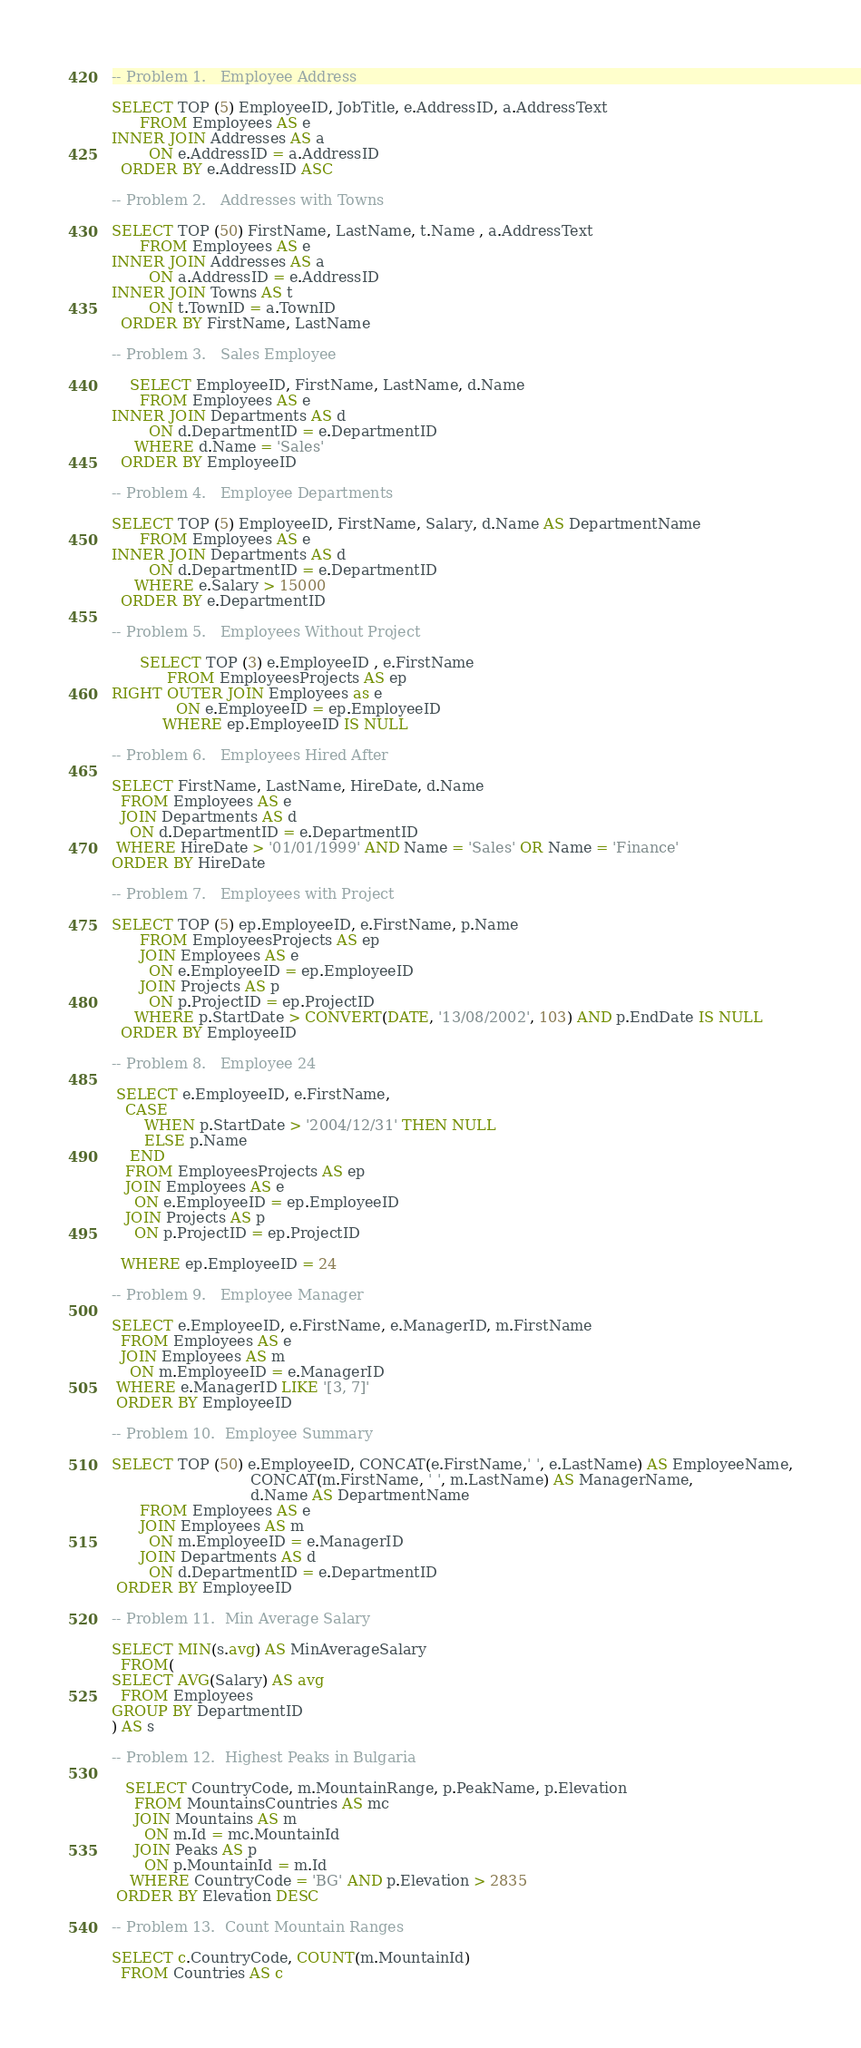Convert code to text. <code><loc_0><loc_0><loc_500><loc_500><_SQL_>-- Problem 1.	Employee Address

SELECT TOP (5) EmployeeID, JobTitle, e.AddressID, a.AddressText
      FROM Employees AS e
INNER JOIN Addresses AS a
        ON e.AddressID = a.AddressID
  ORDER BY e.AddressID ASC

-- Problem 2.	Addresses with Towns

SELECT TOP (50) FirstName, LastName, t.Name , a.AddressText
      FROM Employees AS e
INNER JOIN Addresses AS a
        ON a.AddressID = e.AddressID
INNER JOIN Towns AS t
        ON t.TownID = a.TownID
  ORDER BY FirstName, LastName

-- Problem 3.	Sales Employee

    SELECT EmployeeID, FirstName, LastName, d.Name
      FROM Employees AS e
INNER JOIN Departments AS d
        ON d.DepartmentID = e.DepartmentID
	 WHERE d.Name = 'Sales'
  ORDER BY EmployeeID

-- Problem 4.	Employee Departments

SELECT TOP (5) EmployeeID, FirstName, Salary, d.Name AS DepartmentName
      FROM Employees AS e
INNER JOIN Departments AS d
        ON d.DepartmentID = e.DepartmentID
	 WHERE e.Salary > 15000
  ORDER BY e.DepartmentID

-- Problem 5.	Employees Without Project

      SELECT TOP (3) e.EmployeeID , e.FirstName
            FROM EmployeesProjects AS ep
RIGHT OUTER JOIN Employees as e
              ON e.EmployeeID = ep.EmployeeID
           WHERE ep.EmployeeID IS NULL

-- Problem 6.	Employees Hired After

SELECT FirstName, LastName, HireDate, d.Name
  FROM Employees AS e
  JOIN Departments AS d
    ON d.DepartmentID = e.DepartmentID 
 WHERE HireDate > '01/01/1999' AND Name = 'Sales' OR Name = 'Finance'
ORDER BY HireDate

-- Problem 7.	Employees with Project

SELECT TOP (5) ep.EmployeeID, e.FirstName, p.Name
      FROM EmployeesProjects AS ep
      JOIN Employees AS e
        ON e.EmployeeID = ep.EmployeeID
      JOIN Projects AS p
        ON p.ProjectID = ep.ProjectID
	 WHERE p.StartDate > CONVERT(DATE, '13/08/2002', 103) AND p.EndDate IS NULL
  ORDER BY EmployeeID

-- Problem 8.	Employee 24

 SELECT e.EmployeeID, e.FirstName,
   CASE 
       WHEN p.StartDate > '2004/12/31' THEN NULL
       ELSE p.Name
    END
   FROM EmployeesProjects AS ep
   JOIN Employees AS e
     ON e.EmployeeID = ep.EmployeeID
   JOIN Projects AS p
     ON p.ProjectID = ep.ProjectID

  WHERE ep.EmployeeID = 24

-- Problem 9.	Employee Manager

SELECT e.EmployeeID, e.FirstName, e.ManagerID, m.FirstName
  FROM Employees AS e
  JOIN Employees AS m 
    ON m.EmployeeID = e.ManagerID
 WHERE e.ManagerID LIKE '[3, 7]'
 ORDER BY EmployeeID

-- Problem 10.	Employee Summary

SELECT TOP (50) e.EmployeeID, CONCAT(e.FirstName,' ', e.LastName) AS EmployeeName,
                              CONCAT(m.FirstName, ' ', m.LastName) AS ManagerName,
				              d.Name AS DepartmentName
      FROM Employees AS e
      JOIN Employees AS m
        ON m.EmployeeID = e.ManagerID
      JOIN Departments AS d
        ON d.DepartmentID = e.DepartmentID
 ORDER BY EmployeeID

-- Problem 11.	Min Average Salary

SELECT MIN(s.avg) AS MinAverageSalary
  FROM(
SELECT AVG(Salary) AS avg
  FROM Employees
GROUP BY DepartmentID
) AS s

-- Problem 12.	Highest Peaks in Bulgaria

   SELECT CountryCode, m.MountainRange, p.PeakName, p.Elevation
     FROM MountainsCountries AS mc
     JOIN Mountains AS m
       ON m.Id = mc.MountainId
     JOIN Peaks AS p
       ON p.MountainId = m.Id
    WHERE CountryCode = 'BG' AND p.Elevation > 2835
 ORDER BY Elevation DESC

-- Problem 13.	Count Mountain Ranges

SELECT c.CountryCode, COUNT(m.MountainId)
  FROM Countries AS c</code> 